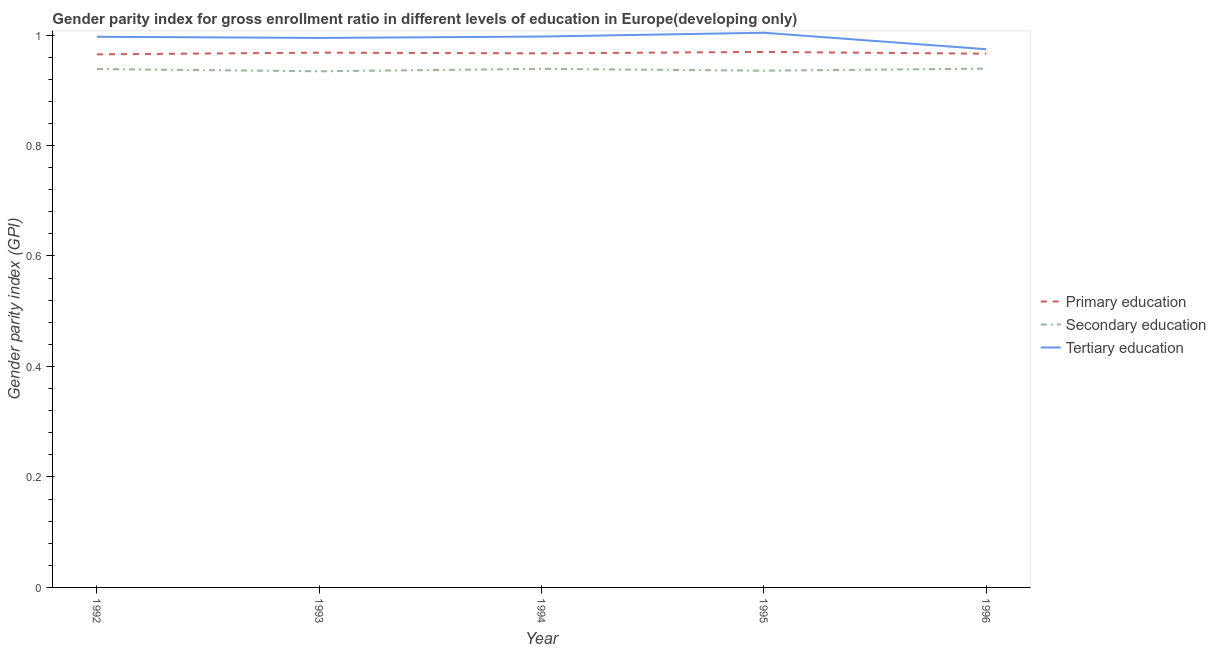How many different coloured lines are there?
Give a very brief answer. 3. Does the line corresponding to gender parity index in secondary education intersect with the line corresponding to gender parity index in tertiary education?
Your answer should be very brief. No. What is the gender parity index in secondary education in 1996?
Keep it short and to the point. 0.94. Across all years, what is the maximum gender parity index in primary education?
Keep it short and to the point. 0.97. Across all years, what is the minimum gender parity index in tertiary education?
Ensure brevity in your answer.  0.97. In which year was the gender parity index in secondary education maximum?
Give a very brief answer. 1996. What is the total gender parity index in secondary education in the graph?
Provide a short and direct response. 4.69. What is the difference between the gender parity index in primary education in 1994 and that in 1995?
Offer a very short reply. -0. What is the difference between the gender parity index in secondary education in 1992 and the gender parity index in primary education in 1996?
Provide a succinct answer. -0.03. What is the average gender parity index in primary education per year?
Your answer should be compact. 0.97. In the year 1992, what is the difference between the gender parity index in secondary education and gender parity index in tertiary education?
Offer a very short reply. -0.06. In how many years, is the gender parity index in tertiary education greater than 0.04?
Offer a terse response. 5. What is the ratio of the gender parity index in secondary education in 1993 to that in 1995?
Give a very brief answer. 1. What is the difference between the highest and the second highest gender parity index in secondary education?
Give a very brief answer. 0. What is the difference between the highest and the lowest gender parity index in secondary education?
Ensure brevity in your answer.  0. Is the gender parity index in secondary education strictly less than the gender parity index in primary education over the years?
Offer a very short reply. Yes. How many lines are there?
Offer a very short reply. 3. How many years are there in the graph?
Keep it short and to the point. 5. What is the difference between two consecutive major ticks on the Y-axis?
Make the answer very short. 0.2. Are the values on the major ticks of Y-axis written in scientific E-notation?
Your answer should be compact. No. Does the graph contain grids?
Keep it short and to the point. No. How are the legend labels stacked?
Keep it short and to the point. Vertical. What is the title of the graph?
Ensure brevity in your answer.  Gender parity index for gross enrollment ratio in different levels of education in Europe(developing only). Does "Liquid fuel" appear as one of the legend labels in the graph?
Make the answer very short. No. What is the label or title of the Y-axis?
Give a very brief answer. Gender parity index (GPI). What is the Gender parity index (GPI) of Primary education in 1992?
Give a very brief answer. 0.97. What is the Gender parity index (GPI) in Secondary education in 1992?
Your answer should be compact. 0.94. What is the Gender parity index (GPI) of Tertiary education in 1992?
Make the answer very short. 1. What is the Gender parity index (GPI) in Primary education in 1993?
Offer a terse response. 0.97. What is the Gender parity index (GPI) of Secondary education in 1993?
Give a very brief answer. 0.93. What is the Gender parity index (GPI) of Tertiary education in 1993?
Your response must be concise. 0.99. What is the Gender parity index (GPI) of Primary education in 1994?
Make the answer very short. 0.97. What is the Gender parity index (GPI) in Secondary education in 1994?
Offer a very short reply. 0.94. What is the Gender parity index (GPI) in Tertiary education in 1994?
Keep it short and to the point. 1. What is the Gender parity index (GPI) in Primary education in 1995?
Offer a very short reply. 0.97. What is the Gender parity index (GPI) of Secondary education in 1995?
Your response must be concise. 0.94. What is the Gender parity index (GPI) of Tertiary education in 1995?
Offer a terse response. 1. What is the Gender parity index (GPI) in Primary education in 1996?
Give a very brief answer. 0.97. What is the Gender parity index (GPI) of Secondary education in 1996?
Ensure brevity in your answer.  0.94. What is the Gender parity index (GPI) in Tertiary education in 1996?
Offer a terse response. 0.97. Across all years, what is the maximum Gender parity index (GPI) in Primary education?
Make the answer very short. 0.97. Across all years, what is the maximum Gender parity index (GPI) of Secondary education?
Your response must be concise. 0.94. Across all years, what is the maximum Gender parity index (GPI) of Tertiary education?
Provide a short and direct response. 1. Across all years, what is the minimum Gender parity index (GPI) in Primary education?
Offer a very short reply. 0.97. Across all years, what is the minimum Gender parity index (GPI) of Secondary education?
Make the answer very short. 0.93. Across all years, what is the minimum Gender parity index (GPI) in Tertiary education?
Offer a very short reply. 0.97. What is the total Gender parity index (GPI) in Primary education in the graph?
Provide a short and direct response. 4.84. What is the total Gender parity index (GPI) in Secondary education in the graph?
Your response must be concise. 4.69. What is the total Gender parity index (GPI) of Tertiary education in the graph?
Keep it short and to the point. 4.97. What is the difference between the Gender parity index (GPI) in Primary education in 1992 and that in 1993?
Give a very brief answer. -0. What is the difference between the Gender parity index (GPI) in Secondary education in 1992 and that in 1993?
Ensure brevity in your answer.  0. What is the difference between the Gender parity index (GPI) of Tertiary education in 1992 and that in 1993?
Ensure brevity in your answer.  0. What is the difference between the Gender parity index (GPI) of Primary education in 1992 and that in 1994?
Your answer should be very brief. -0. What is the difference between the Gender parity index (GPI) of Secondary education in 1992 and that in 1994?
Provide a succinct answer. -0. What is the difference between the Gender parity index (GPI) of Tertiary education in 1992 and that in 1994?
Provide a succinct answer. -0. What is the difference between the Gender parity index (GPI) of Primary education in 1992 and that in 1995?
Make the answer very short. -0. What is the difference between the Gender parity index (GPI) of Secondary education in 1992 and that in 1995?
Make the answer very short. 0. What is the difference between the Gender parity index (GPI) in Tertiary education in 1992 and that in 1995?
Ensure brevity in your answer.  -0.01. What is the difference between the Gender parity index (GPI) of Primary education in 1992 and that in 1996?
Ensure brevity in your answer.  -0. What is the difference between the Gender parity index (GPI) in Secondary education in 1992 and that in 1996?
Offer a very short reply. -0. What is the difference between the Gender parity index (GPI) in Tertiary education in 1992 and that in 1996?
Provide a succinct answer. 0.02. What is the difference between the Gender parity index (GPI) in Primary education in 1993 and that in 1994?
Make the answer very short. 0. What is the difference between the Gender parity index (GPI) in Secondary education in 1993 and that in 1994?
Your answer should be compact. -0. What is the difference between the Gender parity index (GPI) of Tertiary education in 1993 and that in 1994?
Offer a very short reply. -0. What is the difference between the Gender parity index (GPI) of Primary education in 1993 and that in 1995?
Keep it short and to the point. -0. What is the difference between the Gender parity index (GPI) of Secondary education in 1993 and that in 1995?
Give a very brief answer. -0. What is the difference between the Gender parity index (GPI) in Tertiary education in 1993 and that in 1995?
Your answer should be very brief. -0.01. What is the difference between the Gender parity index (GPI) in Primary education in 1993 and that in 1996?
Ensure brevity in your answer.  0. What is the difference between the Gender parity index (GPI) in Secondary education in 1993 and that in 1996?
Make the answer very short. -0. What is the difference between the Gender parity index (GPI) in Tertiary education in 1993 and that in 1996?
Give a very brief answer. 0.02. What is the difference between the Gender parity index (GPI) in Primary education in 1994 and that in 1995?
Your answer should be very brief. -0. What is the difference between the Gender parity index (GPI) of Secondary education in 1994 and that in 1995?
Give a very brief answer. 0. What is the difference between the Gender parity index (GPI) of Tertiary education in 1994 and that in 1995?
Your response must be concise. -0.01. What is the difference between the Gender parity index (GPI) in Primary education in 1994 and that in 1996?
Your response must be concise. 0. What is the difference between the Gender parity index (GPI) of Secondary education in 1994 and that in 1996?
Offer a terse response. -0. What is the difference between the Gender parity index (GPI) of Tertiary education in 1994 and that in 1996?
Your answer should be very brief. 0.02. What is the difference between the Gender parity index (GPI) in Primary education in 1995 and that in 1996?
Offer a very short reply. 0. What is the difference between the Gender parity index (GPI) of Secondary education in 1995 and that in 1996?
Your answer should be compact. -0. What is the difference between the Gender parity index (GPI) of Tertiary education in 1995 and that in 1996?
Your response must be concise. 0.03. What is the difference between the Gender parity index (GPI) of Primary education in 1992 and the Gender parity index (GPI) of Secondary education in 1993?
Offer a very short reply. 0.03. What is the difference between the Gender parity index (GPI) of Primary education in 1992 and the Gender parity index (GPI) of Tertiary education in 1993?
Make the answer very short. -0.03. What is the difference between the Gender parity index (GPI) of Secondary education in 1992 and the Gender parity index (GPI) of Tertiary education in 1993?
Offer a terse response. -0.06. What is the difference between the Gender parity index (GPI) in Primary education in 1992 and the Gender parity index (GPI) in Secondary education in 1994?
Provide a short and direct response. 0.03. What is the difference between the Gender parity index (GPI) of Primary education in 1992 and the Gender parity index (GPI) of Tertiary education in 1994?
Your response must be concise. -0.03. What is the difference between the Gender parity index (GPI) in Secondary education in 1992 and the Gender parity index (GPI) in Tertiary education in 1994?
Your response must be concise. -0.06. What is the difference between the Gender parity index (GPI) in Primary education in 1992 and the Gender parity index (GPI) in Secondary education in 1995?
Your answer should be compact. 0.03. What is the difference between the Gender parity index (GPI) of Primary education in 1992 and the Gender parity index (GPI) of Tertiary education in 1995?
Ensure brevity in your answer.  -0.04. What is the difference between the Gender parity index (GPI) of Secondary education in 1992 and the Gender parity index (GPI) of Tertiary education in 1995?
Provide a short and direct response. -0.07. What is the difference between the Gender parity index (GPI) in Primary education in 1992 and the Gender parity index (GPI) in Secondary education in 1996?
Keep it short and to the point. 0.03. What is the difference between the Gender parity index (GPI) of Primary education in 1992 and the Gender parity index (GPI) of Tertiary education in 1996?
Provide a short and direct response. -0.01. What is the difference between the Gender parity index (GPI) in Secondary education in 1992 and the Gender parity index (GPI) in Tertiary education in 1996?
Offer a terse response. -0.04. What is the difference between the Gender parity index (GPI) of Primary education in 1993 and the Gender parity index (GPI) of Secondary education in 1994?
Your response must be concise. 0.03. What is the difference between the Gender parity index (GPI) in Primary education in 1993 and the Gender parity index (GPI) in Tertiary education in 1994?
Make the answer very short. -0.03. What is the difference between the Gender parity index (GPI) in Secondary education in 1993 and the Gender parity index (GPI) in Tertiary education in 1994?
Offer a very short reply. -0.06. What is the difference between the Gender parity index (GPI) in Primary education in 1993 and the Gender parity index (GPI) in Secondary education in 1995?
Your answer should be very brief. 0.03. What is the difference between the Gender parity index (GPI) in Primary education in 1993 and the Gender parity index (GPI) in Tertiary education in 1995?
Ensure brevity in your answer.  -0.04. What is the difference between the Gender parity index (GPI) in Secondary education in 1993 and the Gender parity index (GPI) in Tertiary education in 1995?
Keep it short and to the point. -0.07. What is the difference between the Gender parity index (GPI) in Primary education in 1993 and the Gender parity index (GPI) in Secondary education in 1996?
Give a very brief answer. 0.03. What is the difference between the Gender parity index (GPI) of Primary education in 1993 and the Gender parity index (GPI) of Tertiary education in 1996?
Your answer should be very brief. -0.01. What is the difference between the Gender parity index (GPI) of Secondary education in 1993 and the Gender parity index (GPI) of Tertiary education in 1996?
Make the answer very short. -0.04. What is the difference between the Gender parity index (GPI) of Primary education in 1994 and the Gender parity index (GPI) of Secondary education in 1995?
Your answer should be compact. 0.03. What is the difference between the Gender parity index (GPI) in Primary education in 1994 and the Gender parity index (GPI) in Tertiary education in 1995?
Make the answer very short. -0.04. What is the difference between the Gender parity index (GPI) of Secondary education in 1994 and the Gender parity index (GPI) of Tertiary education in 1995?
Your response must be concise. -0.07. What is the difference between the Gender parity index (GPI) in Primary education in 1994 and the Gender parity index (GPI) in Secondary education in 1996?
Your answer should be very brief. 0.03. What is the difference between the Gender parity index (GPI) of Primary education in 1994 and the Gender parity index (GPI) of Tertiary education in 1996?
Offer a terse response. -0.01. What is the difference between the Gender parity index (GPI) of Secondary education in 1994 and the Gender parity index (GPI) of Tertiary education in 1996?
Provide a succinct answer. -0.04. What is the difference between the Gender parity index (GPI) of Primary education in 1995 and the Gender parity index (GPI) of Secondary education in 1996?
Your answer should be very brief. 0.03. What is the difference between the Gender parity index (GPI) in Primary education in 1995 and the Gender parity index (GPI) in Tertiary education in 1996?
Provide a succinct answer. -0. What is the difference between the Gender parity index (GPI) of Secondary education in 1995 and the Gender parity index (GPI) of Tertiary education in 1996?
Give a very brief answer. -0.04. What is the average Gender parity index (GPI) in Primary education per year?
Ensure brevity in your answer.  0.97. What is the average Gender parity index (GPI) of Secondary education per year?
Your response must be concise. 0.94. What is the average Gender parity index (GPI) in Tertiary education per year?
Give a very brief answer. 0.99. In the year 1992, what is the difference between the Gender parity index (GPI) in Primary education and Gender parity index (GPI) in Secondary education?
Give a very brief answer. 0.03. In the year 1992, what is the difference between the Gender parity index (GPI) of Primary education and Gender parity index (GPI) of Tertiary education?
Provide a short and direct response. -0.03. In the year 1992, what is the difference between the Gender parity index (GPI) in Secondary education and Gender parity index (GPI) in Tertiary education?
Your answer should be compact. -0.06. In the year 1993, what is the difference between the Gender parity index (GPI) in Primary education and Gender parity index (GPI) in Secondary education?
Your response must be concise. 0.03. In the year 1993, what is the difference between the Gender parity index (GPI) of Primary education and Gender parity index (GPI) of Tertiary education?
Provide a succinct answer. -0.03. In the year 1993, what is the difference between the Gender parity index (GPI) in Secondary education and Gender parity index (GPI) in Tertiary education?
Ensure brevity in your answer.  -0.06. In the year 1994, what is the difference between the Gender parity index (GPI) of Primary education and Gender parity index (GPI) of Secondary education?
Make the answer very short. 0.03. In the year 1994, what is the difference between the Gender parity index (GPI) in Primary education and Gender parity index (GPI) in Tertiary education?
Your answer should be very brief. -0.03. In the year 1994, what is the difference between the Gender parity index (GPI) of Secondary education and Gender parity index (GPI) of Tertiary education?
Provide a short and direct response. -0.06. In the year 1995, what is the difference between the Gender parity index (GPI) of Primary education and Gender parity index (GPI) of Secondary education?
Make the answer very short. 0.03. In the year 1995, what is the difference between the Gender parity index (GPI) of Primary education and Gender parity index (GPI) of Tertiary education?
Provide a succinct answer. -0.03. In the year 1995, what is the difference between the Gender parity index (GPI) in Secondary education and Gender parity index (GPI) in Tertiary education?
Your answer should be very brief. -0.07. In the year 1996, what is the difference between the Gender parity index (GPI) of Primary education and Gender parity index (GPI) of Secondary education?
Ensure brevity in your answer.  0.03. In the year 1996, what is the difference between the Gender parity index (GPI) in Primary education and Gender parity index (GPI) in Tertiary education?
Make the answer very short. -0.01. In the year 1996, what is the difference between the Gender parity index (GPI) in Secondary education and Gender parity index (GPI) in Tertiary education?
Provide a short and direct response. -0.04. What is the ratio of the Gender parity index (GPI) in Secondary education in 1992 to that in 1993?
Your response must be concise. 1. What is the ratio of the Gender parity index (GPI) of Primary education in 1992 to that in 1995?
Give a very brief answer. 1. What is the ratio of the Gender parity index (GPI) of Secondary education in 1992 to that in 1995?
Your answer should be compact. 1. What is the ratio of the Gender parity index (GPI) of Tertiary education in 1992 to that in 1995?
Offer a very short reply. 0.99. What is the ratio of the Gender parity index (GPI) of Tertiary education in 1992 to that in 1996?
Your answer should be very brief. 1.02. What is the ratio of the Gender parity index (GPI) in Secondary education in 1993 to that in 1994?
Your answer should be compact. 1. What is the ratio of the Gender parity index (GPI) in Secondary education in 1993 to that in 1995?
Provide a short and direct response. 1. What is the ratio of the Gender parity index (GPI) in Tertiary education in 1993 to that in 1995?
Offer a terse response. 0.99. What is the ratio of the Gender parity index (GPI) in Primary education in 1993 to that in 1996?
Keep it short and to the point. 1. What is the ratio of the Gender parity index (GPI) in Secondary education in 1993 to that in 1996?
Provide a short and direct response. 0.99. What is the ratio of the Gender parity index (GPI) in Tertiary education in 1993 to that in 1996?
Give a very brief answer. 1.02. What is the ratio of the Gender parity index (GPI) in Secondary education in 1994 to that in 1995?
Ensure brevity in your answer.  1. What is the ratio of the Gender parity index (GPI) in Tertiary education in 1994 to that in 1995?
Offer a very short reply. 0.99. What is the ratio of the Gender parity index (GPI) in Secondary education in 1994 to that in 1996?
Offer a very short reply. 1. What is the ratio of the Gender parity index (GPI) in Tertiary education in 1994 to that in 1996?
Provide a short and direct response. 1.02. What is the ratio of the Gender parity index (GPI) of Primary education in 1995 to that in 1996?
Offer a terse response. 1. What is the ratio of the Gender parity index (GPI) of Secondary education in 1995 to that in 1996?
Your response must be concise. 1. What is the ratio of the Gender parity index (GPI) of Tertiary education in 1995 to that in 1996?
Ensure brevity in your answer.  1.03. What is the difference between the highest and the second highest Gender parity index (GPI) in Primary education?
Offer a very short reply. 0. What is the difference between the highest and the second highest Gender parity index (GPI) of Tertiary education?
Offer a terse response. 0.01. What is the difference between the highest and the lowest Gender parity index (GPI) of Primary education?
Offer a very short reply. 0. What is the difference between the highest and the lowest Gender parity index (GPI) of Secondary education?
Give a very brief answer. 0. What is the difference between the highest and the lowest Gender parity index (GPI) in Tertiary education?
Make the answer very short. 0.03. 